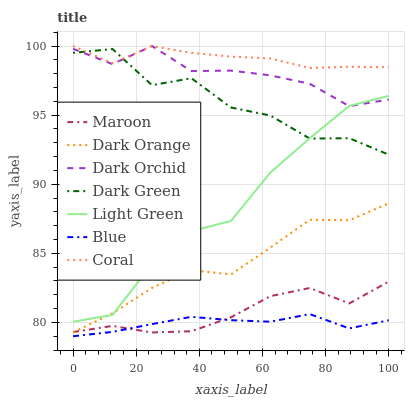Does Blue have the minimum area under the curve?
Answer yes or no. Yes. Does Coral have the maximum area under the curve?
Answer yes or no. Yes. Does Dark Orange have the minimum area under the curve?
Answer yes or no. No. Does Dark Orange have the maximum area under the curve?
Answer yes or no. No. Is Blue the smoothest?
Answer yes or no. Yes. Is Dark Green the roughest?
Answer yes or no. Yes. Is Dark Orange the smoothest?
Answer yes or no. No. Is Dark Orange the roughest?
Answer yes or no. No. Does Blue have the lowest value?
Answer yes or no. Yes. Does Dark Orange have the lowest value?
Answer yes or no. No. Does Dark Orchid have the highest value?
Answer yes or no. Yes. Does Dark Orange have the highest value?
Answer yes or no. No. Is Dark Orange less than Coral?
Answer yes or no. Yes. Is Dark Orchid greater than Blue?
Answer yes or no. Yes. Does Dark Orchid intersect Light Green?
Answer yes or no. Yes. Is Dark Orchid less than Light Green?
Answer yes or no. No. Is Dark Orchid greater than Light Green?
Answer yes or no. No. Does Dark Orange intersect Coral?
Answer yes or no. No. 